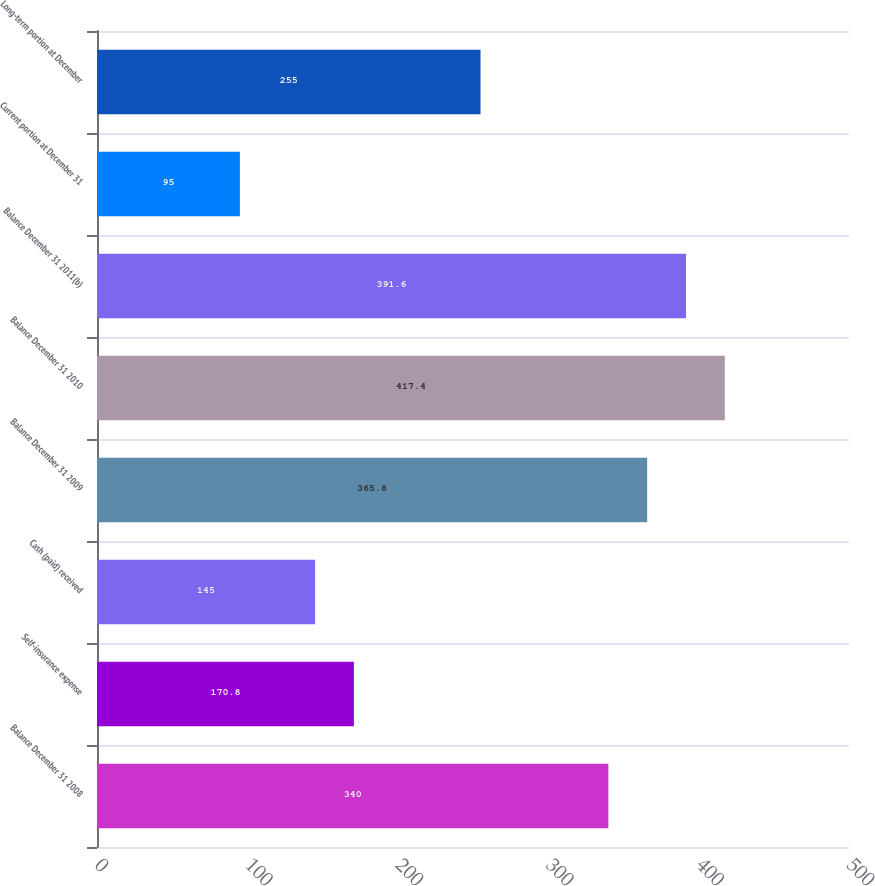<chart> <loc_0><loc_0><loc_500><loc_500><bar_chart><fcel>Balance December 31 2008<fcel>Self-insurance expense<fcel>Cash (paid) received<fcel>Balance December 31 2009<fcel>Balance December 31 2010<fcel>Balance December 31 2011(b)<fcel>Current portion at December 31<fcel>Long-term portion at December<nl><fcel>340<fcel>170.8<fcel>145<fcel>365.8<fcel>417.4<fcel>391.6<fcel>95<fcel>255<nl></chart> 